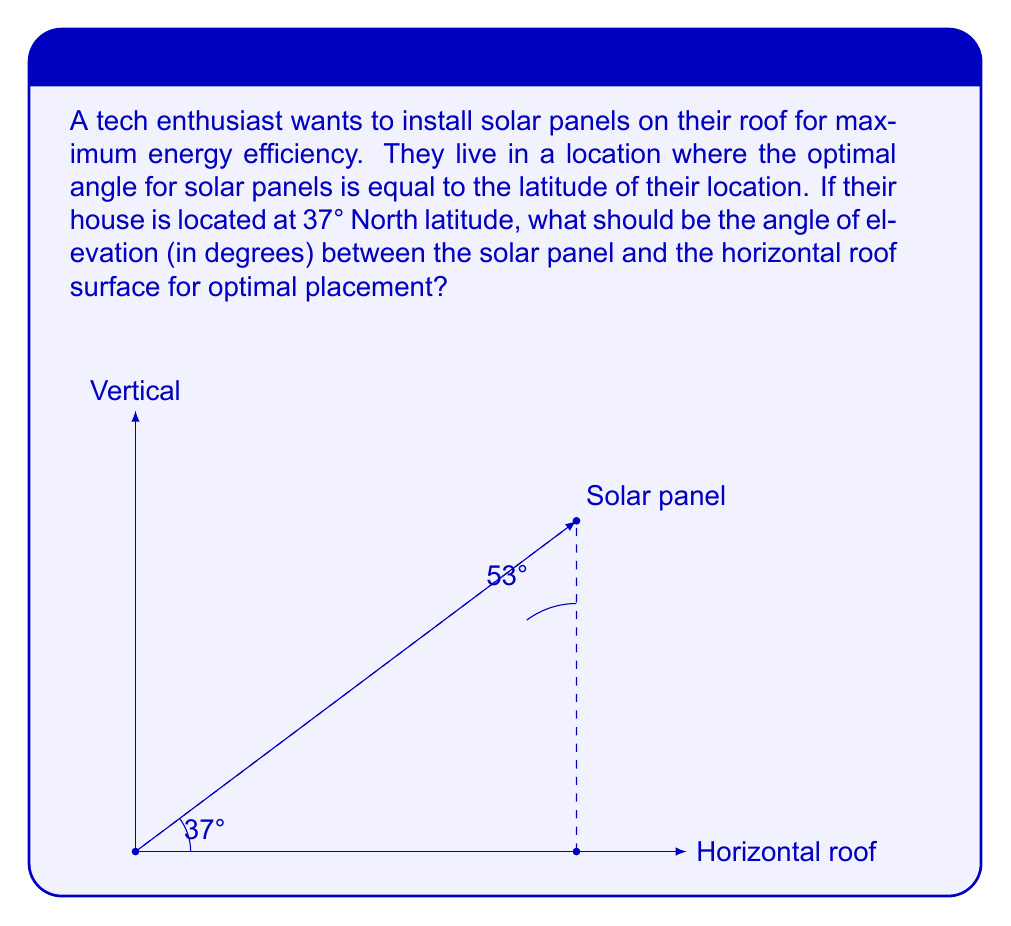Could you help me with this problem? To solve this problem, we need to understand the relationship between the angle of elevation and the latitude:

1) The optimal angle for solar panels is equal to the latitude of the location.
2) The angle of elevation is measured from the horizontal surface.
3) The sum of the angle of elevation and the optimal angle (latitude) must equal 90° (a right angle).

Let's solve step-by-step:

1) Let $x$ be the angle of elevation we're looking for.
2) We know the latitude is 37°.
3) We can set up the equation:

   $x + 37° = 90°$

4) Solving for $x$:

   $x = 90° - 37°$
   $x = 53°$

Therefore, the angle of elevation for optimal solar panel placement should be 53°.

This can be verified geometrically: the solar panel forms a right triangle with the roof and a vertical line. The angle between the panel and the vertical line is equal to the latitude (37°), so the complementary angle between the panel and the roof must be 90° - 37° = 53°.
Answer: $53°$ 